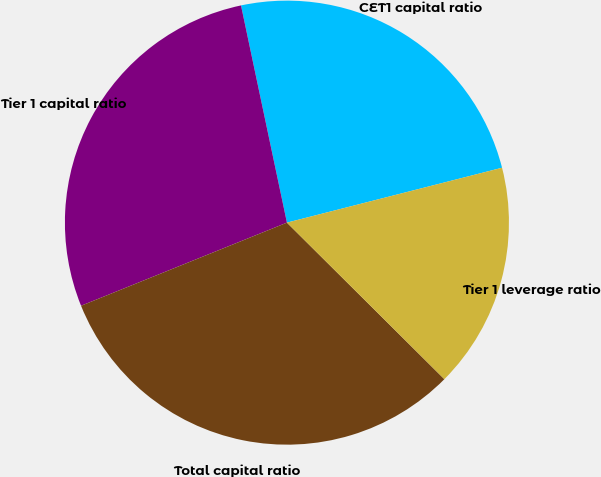<chart> <loc_0><loc_0><loc_500><loc_500><pie_chart><fcel>CET1 capital ratio<fcel>Tier 1 capital ratio<fcel>Total capital ratio<fcel>Tier 1 leverage ratio<nl><fcel>24.34%<fcel>27.79%<fcel>31.44%<fcel>16.43%<nl></chart> 